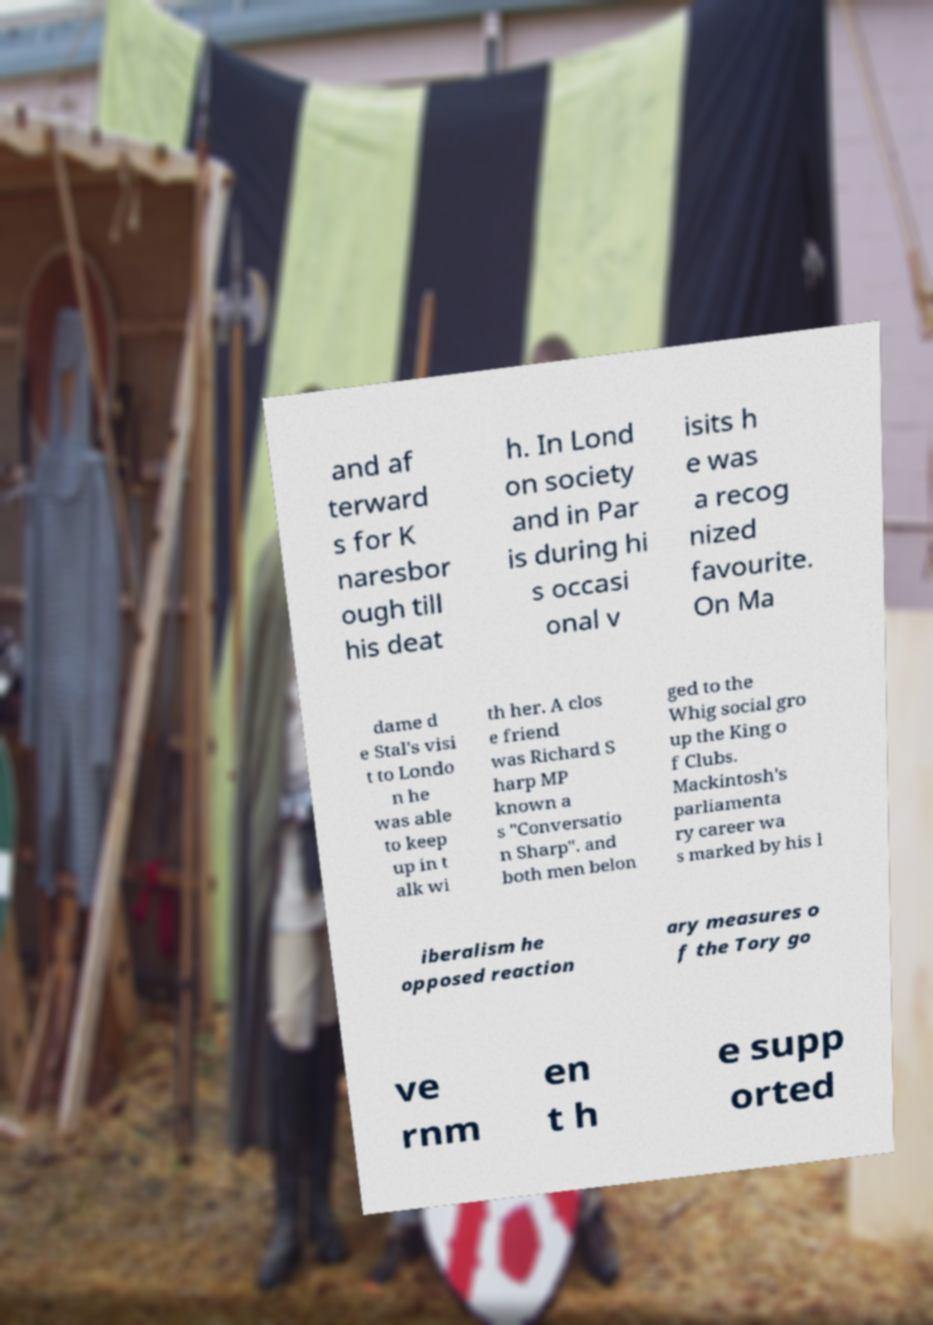There's text embedded in this image that I need extracted. Can you transcribe it verbatim? and af terward s for K naresbor ough till his deat h. In Lond on society and in Par is during hi s occasi onal v isits h e was a recog nized favourite. On Ma dame d e Stal's visi t to Londo n he was able to keep up in t alk wi th her. A clos e friend was Richard S harp MP known a s "Conversatio n Sharp". and both men belon ged to the Whig social gro up the King o f Clubs. Mackintosh's parliamenta ry career wa s marked by his l iberalism he opposed reaction ary measures o f the Tory go ve rnm en t h e supp orted 